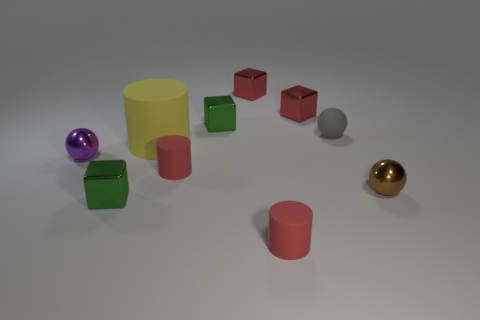Subtract all cylinders. How many objects are left? 7 Add 9 big yellow things. How many big yellow things are left? 10 Add 7 spheres. How many spheres exist? 10 Subtract 0 yellow cubes. How many objects are left? 10 Subtract all small rubber spheres. Subtract all yellow rubber objects. How many objects are left? 8 